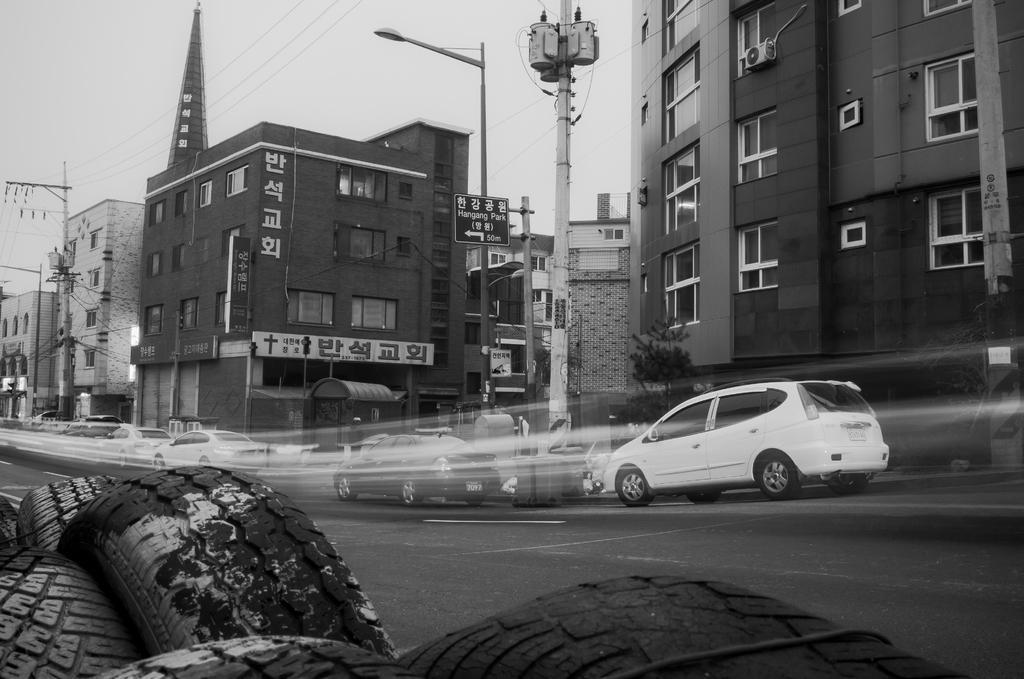Can you describe this image briefly? It is a black and white image. On the left side there are Tyres, in the middle few cars are moving, on the right side there are buildings. 